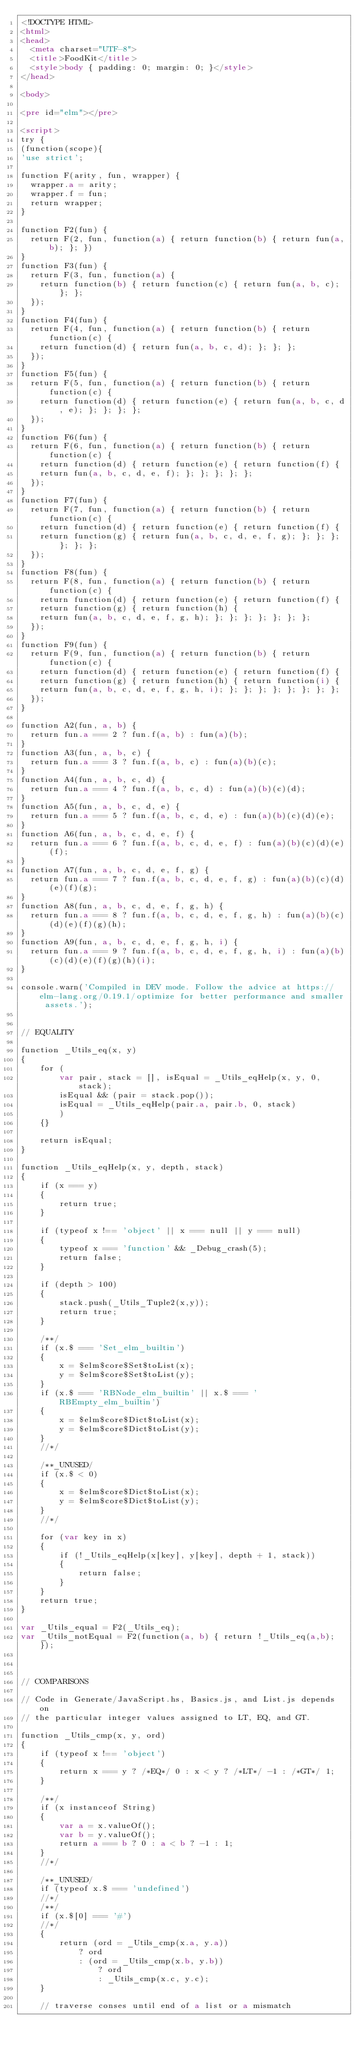<code> <loc_0><loc_0><loc_500><loc_500><_HTML_><!DOCTYPE HTML>
<html>
<head>
  <meta charset="UTF-8">
  <title>FoodKit</title>
  <style>body { padding: 0; margin: 0; }</style>
</head>

<body>

<pre id="elm"></pre>

<script>
try {
(function(scope){
'use strict';

function F(arity, fun, wrapper) {
  wrapper.a = arity;
  wrapper.f = fun;
  return wrapper;
}

function F2(fun) {
  return F(2, fun, function(a) { return function(b) { return fun(a,b); }; })
}
function F3(fun) {
  return F(3, fun, function(a) {
    return function(b) { return function(c) { return fun(a, b, c); }; };
  });
}
function F4(fun) {
  return F(4, fun, function(a) { return function(b) { return function(c) {
    return function(d) { return fun(a, b, c, d); }; }; };
  });
}
function F5(fun) {
  return F(5, fun, function(a) { return function(b) { return function(c) {
    return function(d) { return function(e) { return fun(a, b, c, d, e); }; }; }; };
  });
}
function F6(fun) {
  return F(6, fun, function(a) { return function(b) { return function(c) {
    return function(d) { return function(e) { return function(f) {
    return fun(a, b, c, d, e, f); }; }; }; }; };
  });
}
function F7(fun) {
  return F(7, fun, function(a) { return function(b) { return function(c) {
    return function(d) { return function(e) { return function(f) {
    return function(g) { return fun(a, b, c, d, e, f, g); }; }; }; }; }; };
  });
}
function F8(fun) {
  return F(8, fun, function(a) { return function(b) { return function(c) {
    return function(d) { return function(e) { return function(f) {
    return function(g) { return function(h) {
    return fun(a, b, c, d, e, f, g, h); }; }; }; }; }; }; };
  });
}
function F9(fun) {
  return F(9, fun, function(a) { return function(b) { return function(c) {
    return function(d) { return function(e) { return function(f) {
    return function(g) { return function(h) { return function(i) {
    return fun(a, b, c, d, e, f, g, h, i); }; }; }; }; }; }; }; };
  });
}

function A2(fun, a, b) {
  return fun.a === 2 ? fun.f(a, b) : fun(a)(b);
}
function A3(fun, a, b, c) {
  return fun.a === 3 ? fun.f(a, b, c) : fun(a)(b)(c);
}
function A4(fun, a, b, c, d) {
  return fun.a === 4 ? fun.f(a, b, c, d) : fun(a)(b)(c)(d);
}
function A5(fun, a, b, c, d, e) {
  return fun.a === 5 ? fun.f(a, b, c, d, e) : fun(a)(b)(c)(d)(e);
}
function A6(fun, a, b, c, d, e, f) {
  return fun.a === 6 ? fun.f(a, b, c, d, e, f) : fun(a)(b)(c)(d)(e)(f);
}
function A7(fun, a, b, c, d, e, f, g) {
  return fun.a === 7 ? fun.f(a, b, c, d, e, f, g) : fun(a)(b)(c)(d)(e)(f)(g);
}
function A8(fun, a, b, c, d, e, f, g, h) {
  return fun.a === 8 ? fun.f(a, b, c, d, e, f, g, h) : fun(a)(b)(c)(d)(e)(f)(g)(h);
}
function A9(fun, a, b, c, d, e, f, g, h, i) {
  return fun.a === 9 ? fun.f(a, b, c, d, e, f, g, h, i) : fun(a)(b)(c)(d)(e)(f)(g)(h)(i);
}

console.warn('Compiled in DEV mode. Follow the advice at https://elm-lang.org/0.19.1/optimize for better performance and smaller assets.');


// EQUALITY

function _Utils_eq(x, y)
{
	for (
		var pair, stack = [], isEqual = _Utils_eqHelp(x, y, 0, stack);
		isEqual && (pair = stack.pop());
		isEqual = _Utils_eqHelp(pair.a, pair.b, 0, stack)
		)
	{}

	return isEqual;
}

function _Utils_eqHelp(x, y, depth, stack)
{
	if (x === y)
	{
		return true;
	}

	if (typeof x !== 'object' || x === null || y === null)
	{
		typeof x === 'function' && _Debug_crash(5);
		return false;
	}

	if (depth > 100)
	{
		stack.push(_Utils_Tuple2(x,y));
		return true;
	}

	/**/
	if (x.$ === 'Set_elm_builtin')
	{
		x = $elm$core$Set$toList(x);
		y = $elm$core$Set$toList(y);
	}
	if (x.$ === 'RBNode_elm_builtin' || x.$ === 'RBEmpty_elm_builtin')
	{
		x = $elm$core$Dict$toList(x);
		y = $elm$core$Dict$toList(y);
	}
	//*/

	/**_UNUSED/
	if (x.$ < 0)
	{
		x = $elm$core$Dict$toList(x);
		y = $elm$core$Dict$toList(y);
	}
	//*/

	for (var key in x)
	{
		if (!_Utils_eqHelp(x[key], y[key], depth + 1, stack))
		{
			return false;
		}
	}
	return true;
}

var _Utils_equal = F2(_Utils_eq);
var _Utils_notEqual = F2(function(a, b) { return !_Utils_eq(a,b); });



// COMPARISONS

// Code in Generate/JavaScript.hs, Basics.js, and List.js depends on
// the particular integer values assigned to LT, EQ, and GT.

function _Utils_cmp(x, y, ord)
{
	if (typeof x !== 'object')
	{
		return x === y ? /*EQ*/ 0 : x < y ? /*LT*/ -1 : /*GT*/ 1;
	}

	/**/
	if (x instanceof String)
	{
		var a = x.valueOf();
		var b = y.valueOf();
		return a === b ? 0 : a < b ? -1 : 1;
	}
	//*/

	/**_UNUSED/
	if (typeof x.$ === 'undefined')
	//*/
	/**/
	if (x.$[0] === '#')
	//*/
	{
		return (ord = _Utils_cmp(x.a, y.a))
			? ord
			: (ord = _Utils_cmp(x.b, y.b))
				? ord
				: _Utils_cmp(x.c, y.c);
	}

	// traverse conses until end of a list or a mismatch</code> 